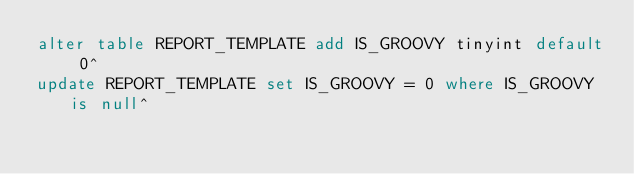Convert code to text. <code><loc_0><loc_0><loc_500><loc_500><_SQL_>alter table REPORT_TEMPLATE add IS_GROOVY tinyint default 0^
update REPORT_TEMPLATE set IS_GROOVY = 0 where IS_GROOVY is null^</code> 